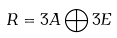Convert formula to latex. <formula><loc_0><loc_0><loc_500><loc_500>R = 3 A \bigoplus 3 E</formula> 